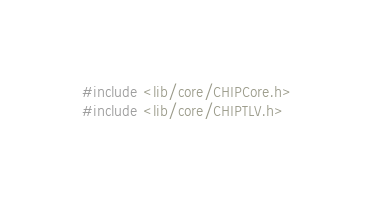<code> <loc_0><loc_0><loc_500><loc_500><_C_>#include <lib/core/CHIPCore.h>
#include <lib/core/CHIPTLV.h></code> 